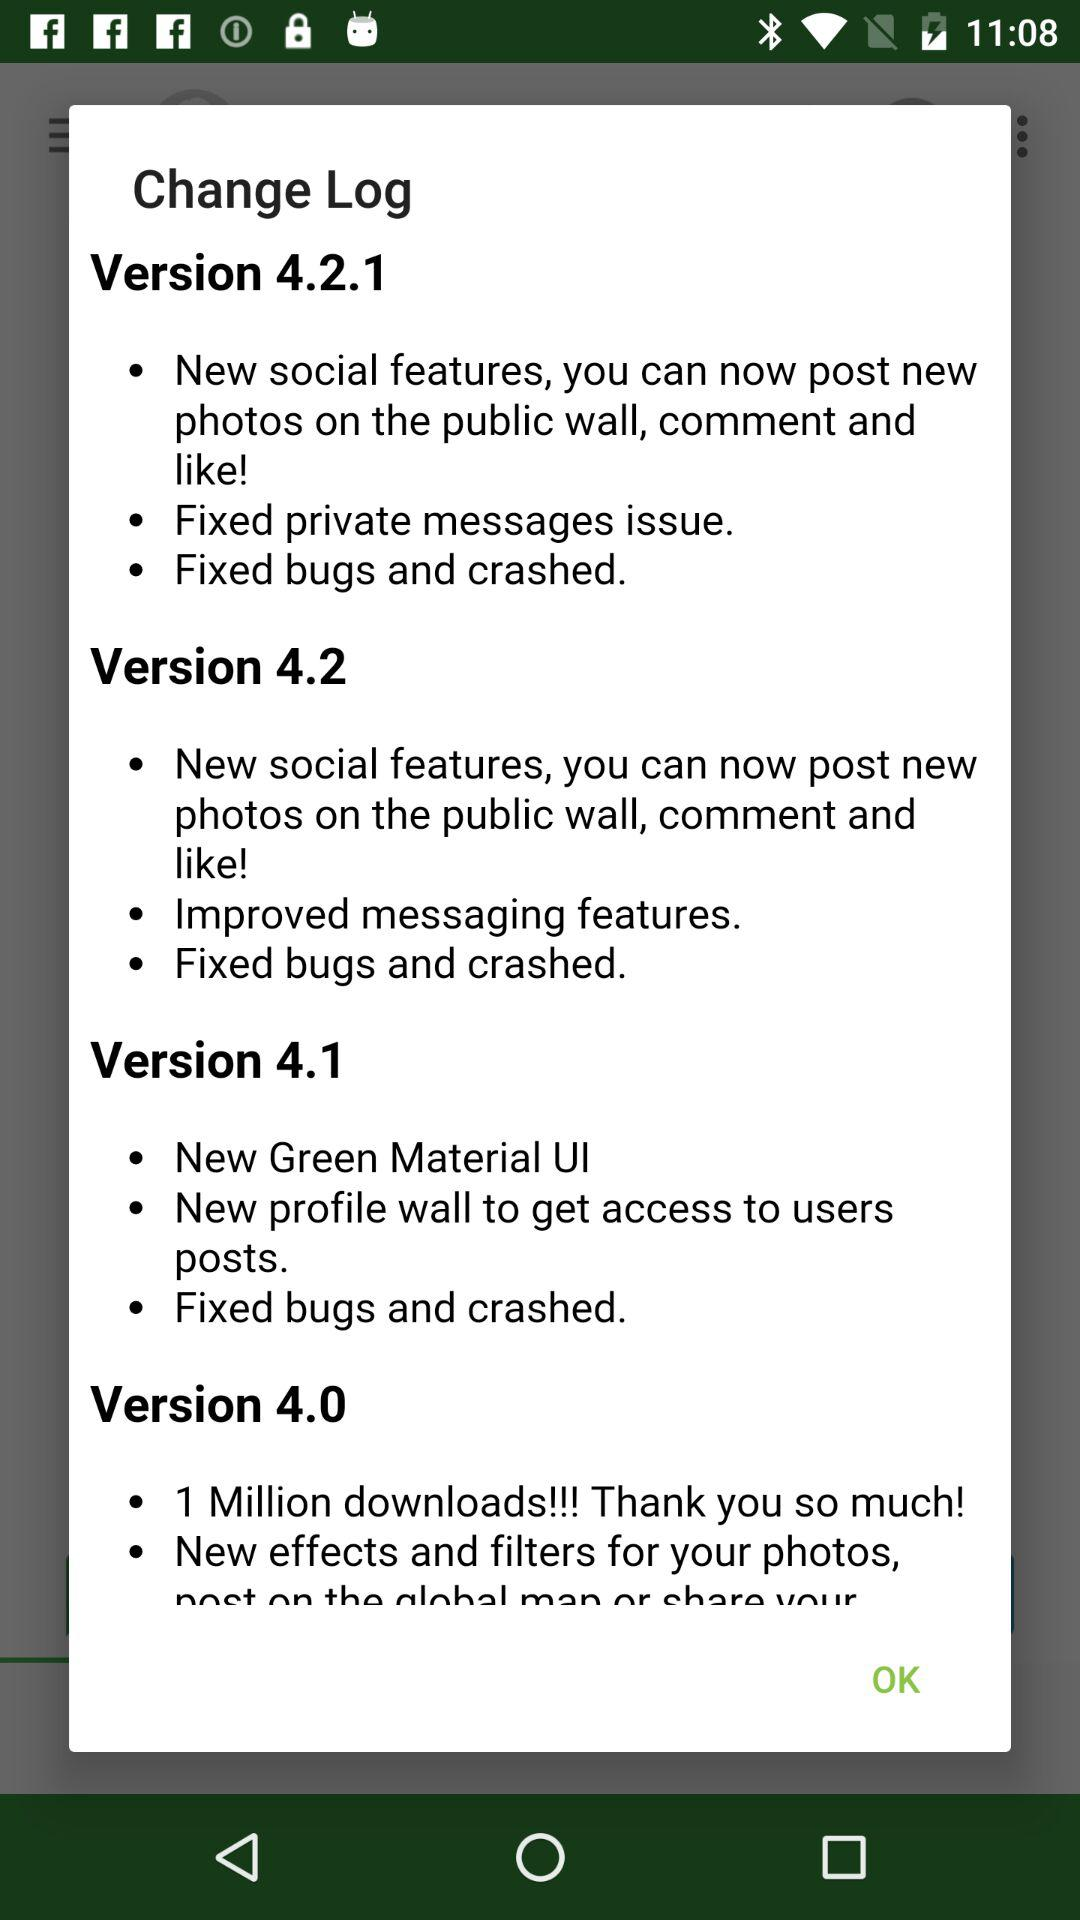What is the latest version of the application being used?
Answer the question using a single word or phrase. The latest version of the application being used is Version 4.2.1 